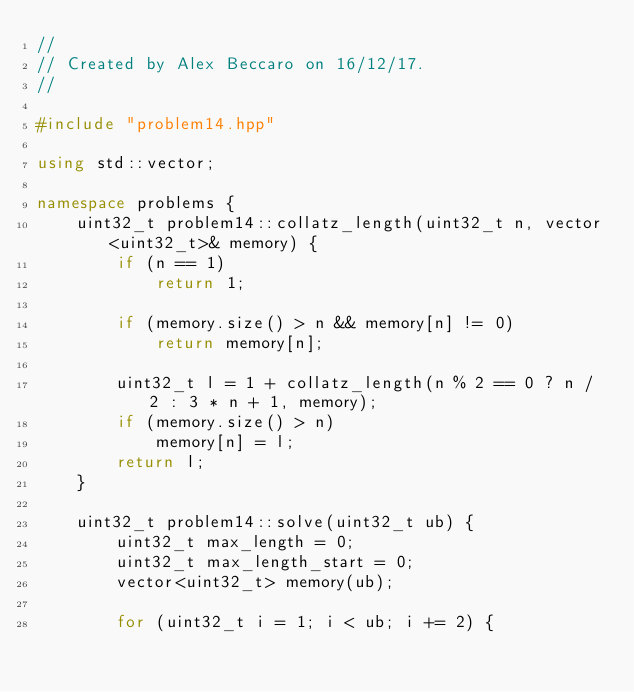Convert code to text. <code><loc_0><loc_0><loc_500><loc_500><_C++_>//
// Created by Alex Beccaro on 16/12/17.
//

#include "problem14.hpp"

using std::vector;

namespace problems {
    uint32_t problem14::collatz_length(uint32_t n, vector<uint32_t>& memory) {
        if (n == 1)
            return 1;

        if (memory.size() > n && memory[n] != 0)
            return memory[n];

        uint32_t l = 1 + collatz_length(n % 2 == 0 ? n / 2 : 3 * n + 1, memory);
        if (memory.size() > n)
            memory[n] = l;
        return l;
    }

    uint32_t problem14::solve(uint32_t ub) {
        uint32_t max_length = 0;
        uint32_t max_length_start = 0;
        vector<uint32_t> memory(ub);

        for (uint32_t i = 1; i < ub; i += 2) {</code> 